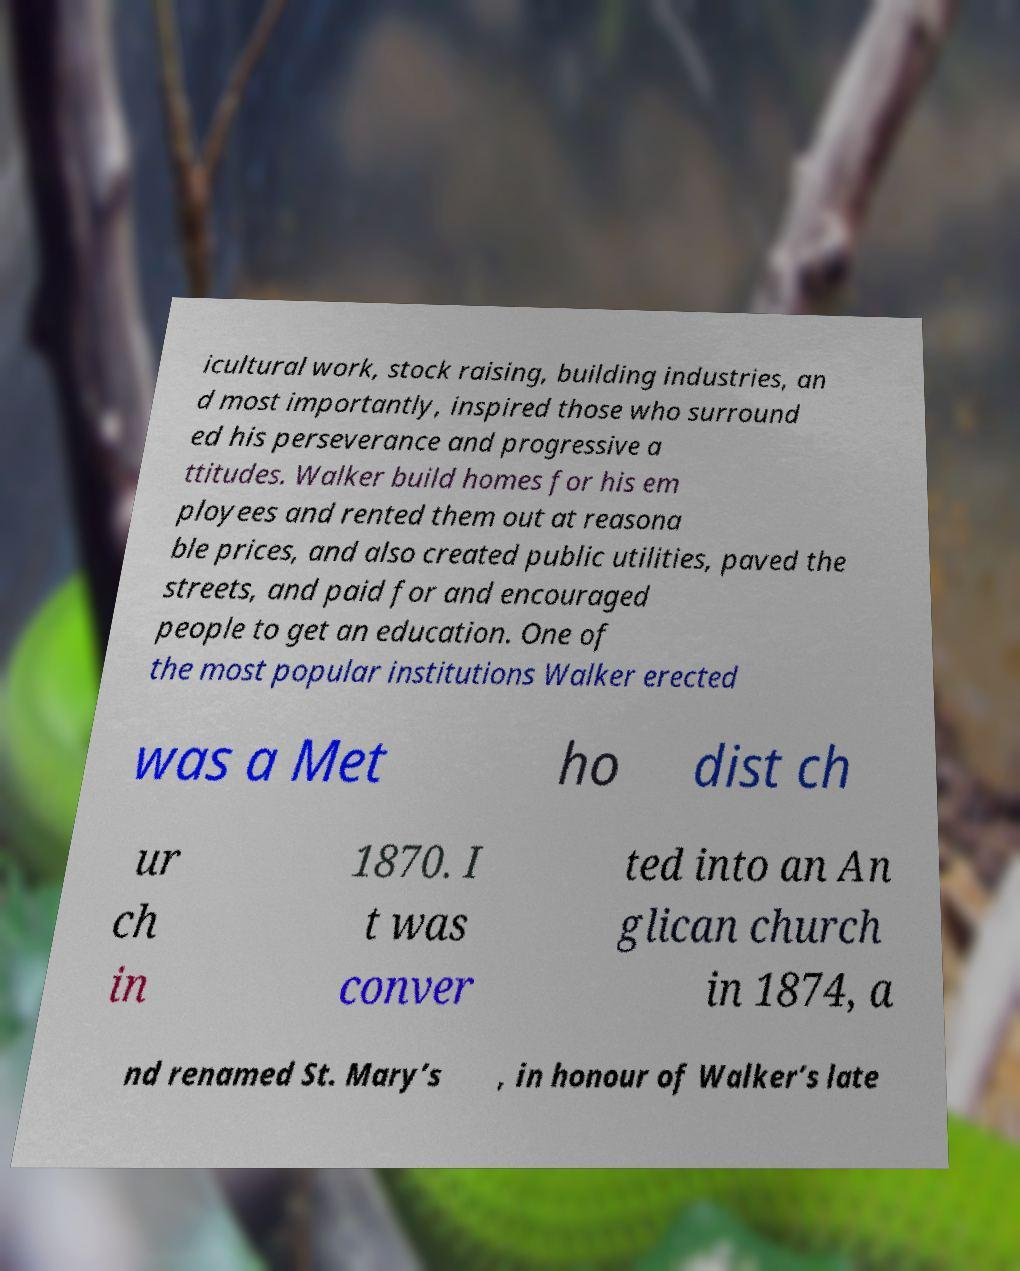Could you assist in decoding the text presented in this image and type it out clearly? icultural work, stock raising, building industries, an d most importantly, inspired those who surround ed his perseverance and progressive a ttitudes. Walker build homes for his em ployees and rented them out at reasona ble prices, and also created public utilities, paved the streets, and paid for and encouraged people to get an education. One of the most popular institutions Walker erected was a Met ho dist ch ur ch in 1870. I t was conver ted into an An glican church in 1874, a nd renamed St. Mary’s , in honour of Walker’s late 